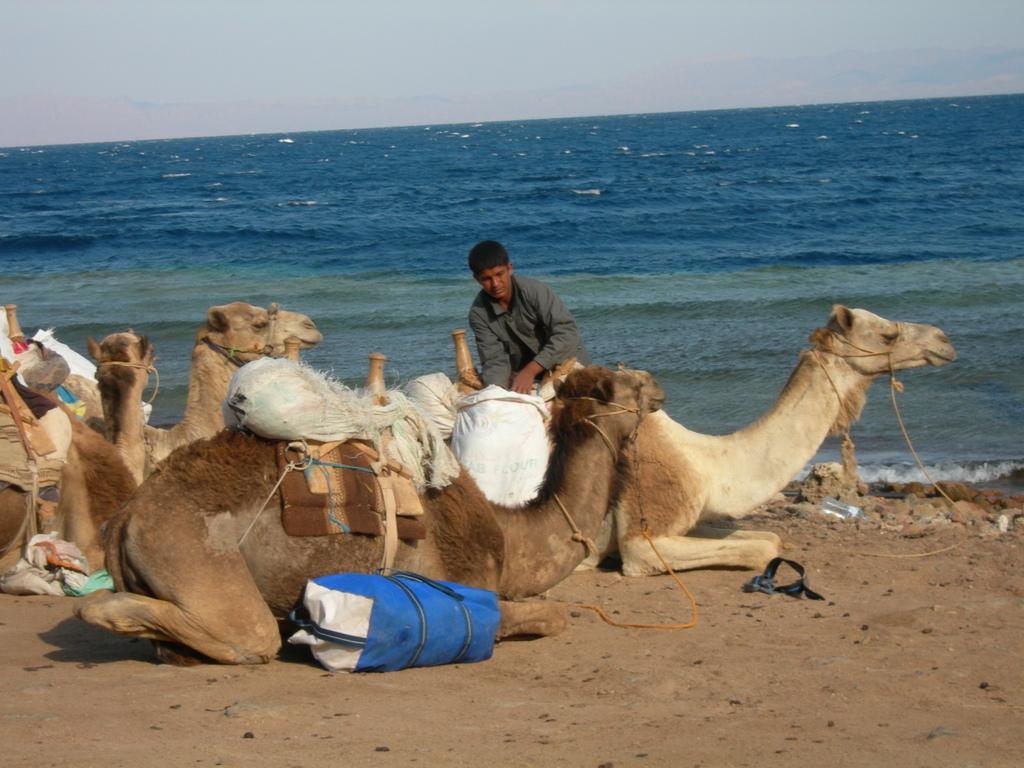Describe this image in one or two sentences. In the picture I can see camels carrying bags and one person is sitting on the camel, behind we can see full of water. 